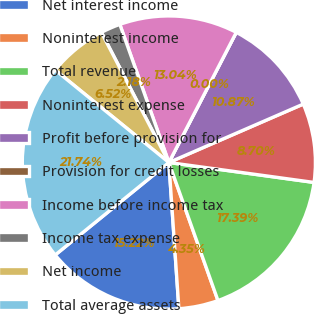Convert chart to OTSL. <chart><loc_0><loc_0><loc_500><loc_500><pie_chart><fcel>Net interest income<fcel>Noninterest income<fcel>Total revenue<fcel>Noninterest expense<fcel>Profit before provision for<fcel>Provision for credit losses<fcel>Income before income tax<fcel>Income tax expense<fcel>Net income<fcel>Total average assets<nl><fcel>15.22%<fcel>4.35%<fcel>17.39%<fcel>8.7%<fcel>10.87%<fcel>0.0%<fcel>13.04%<fcel>2.18%<fcel>6.52%<fcel>21.74%<nl></chart> 